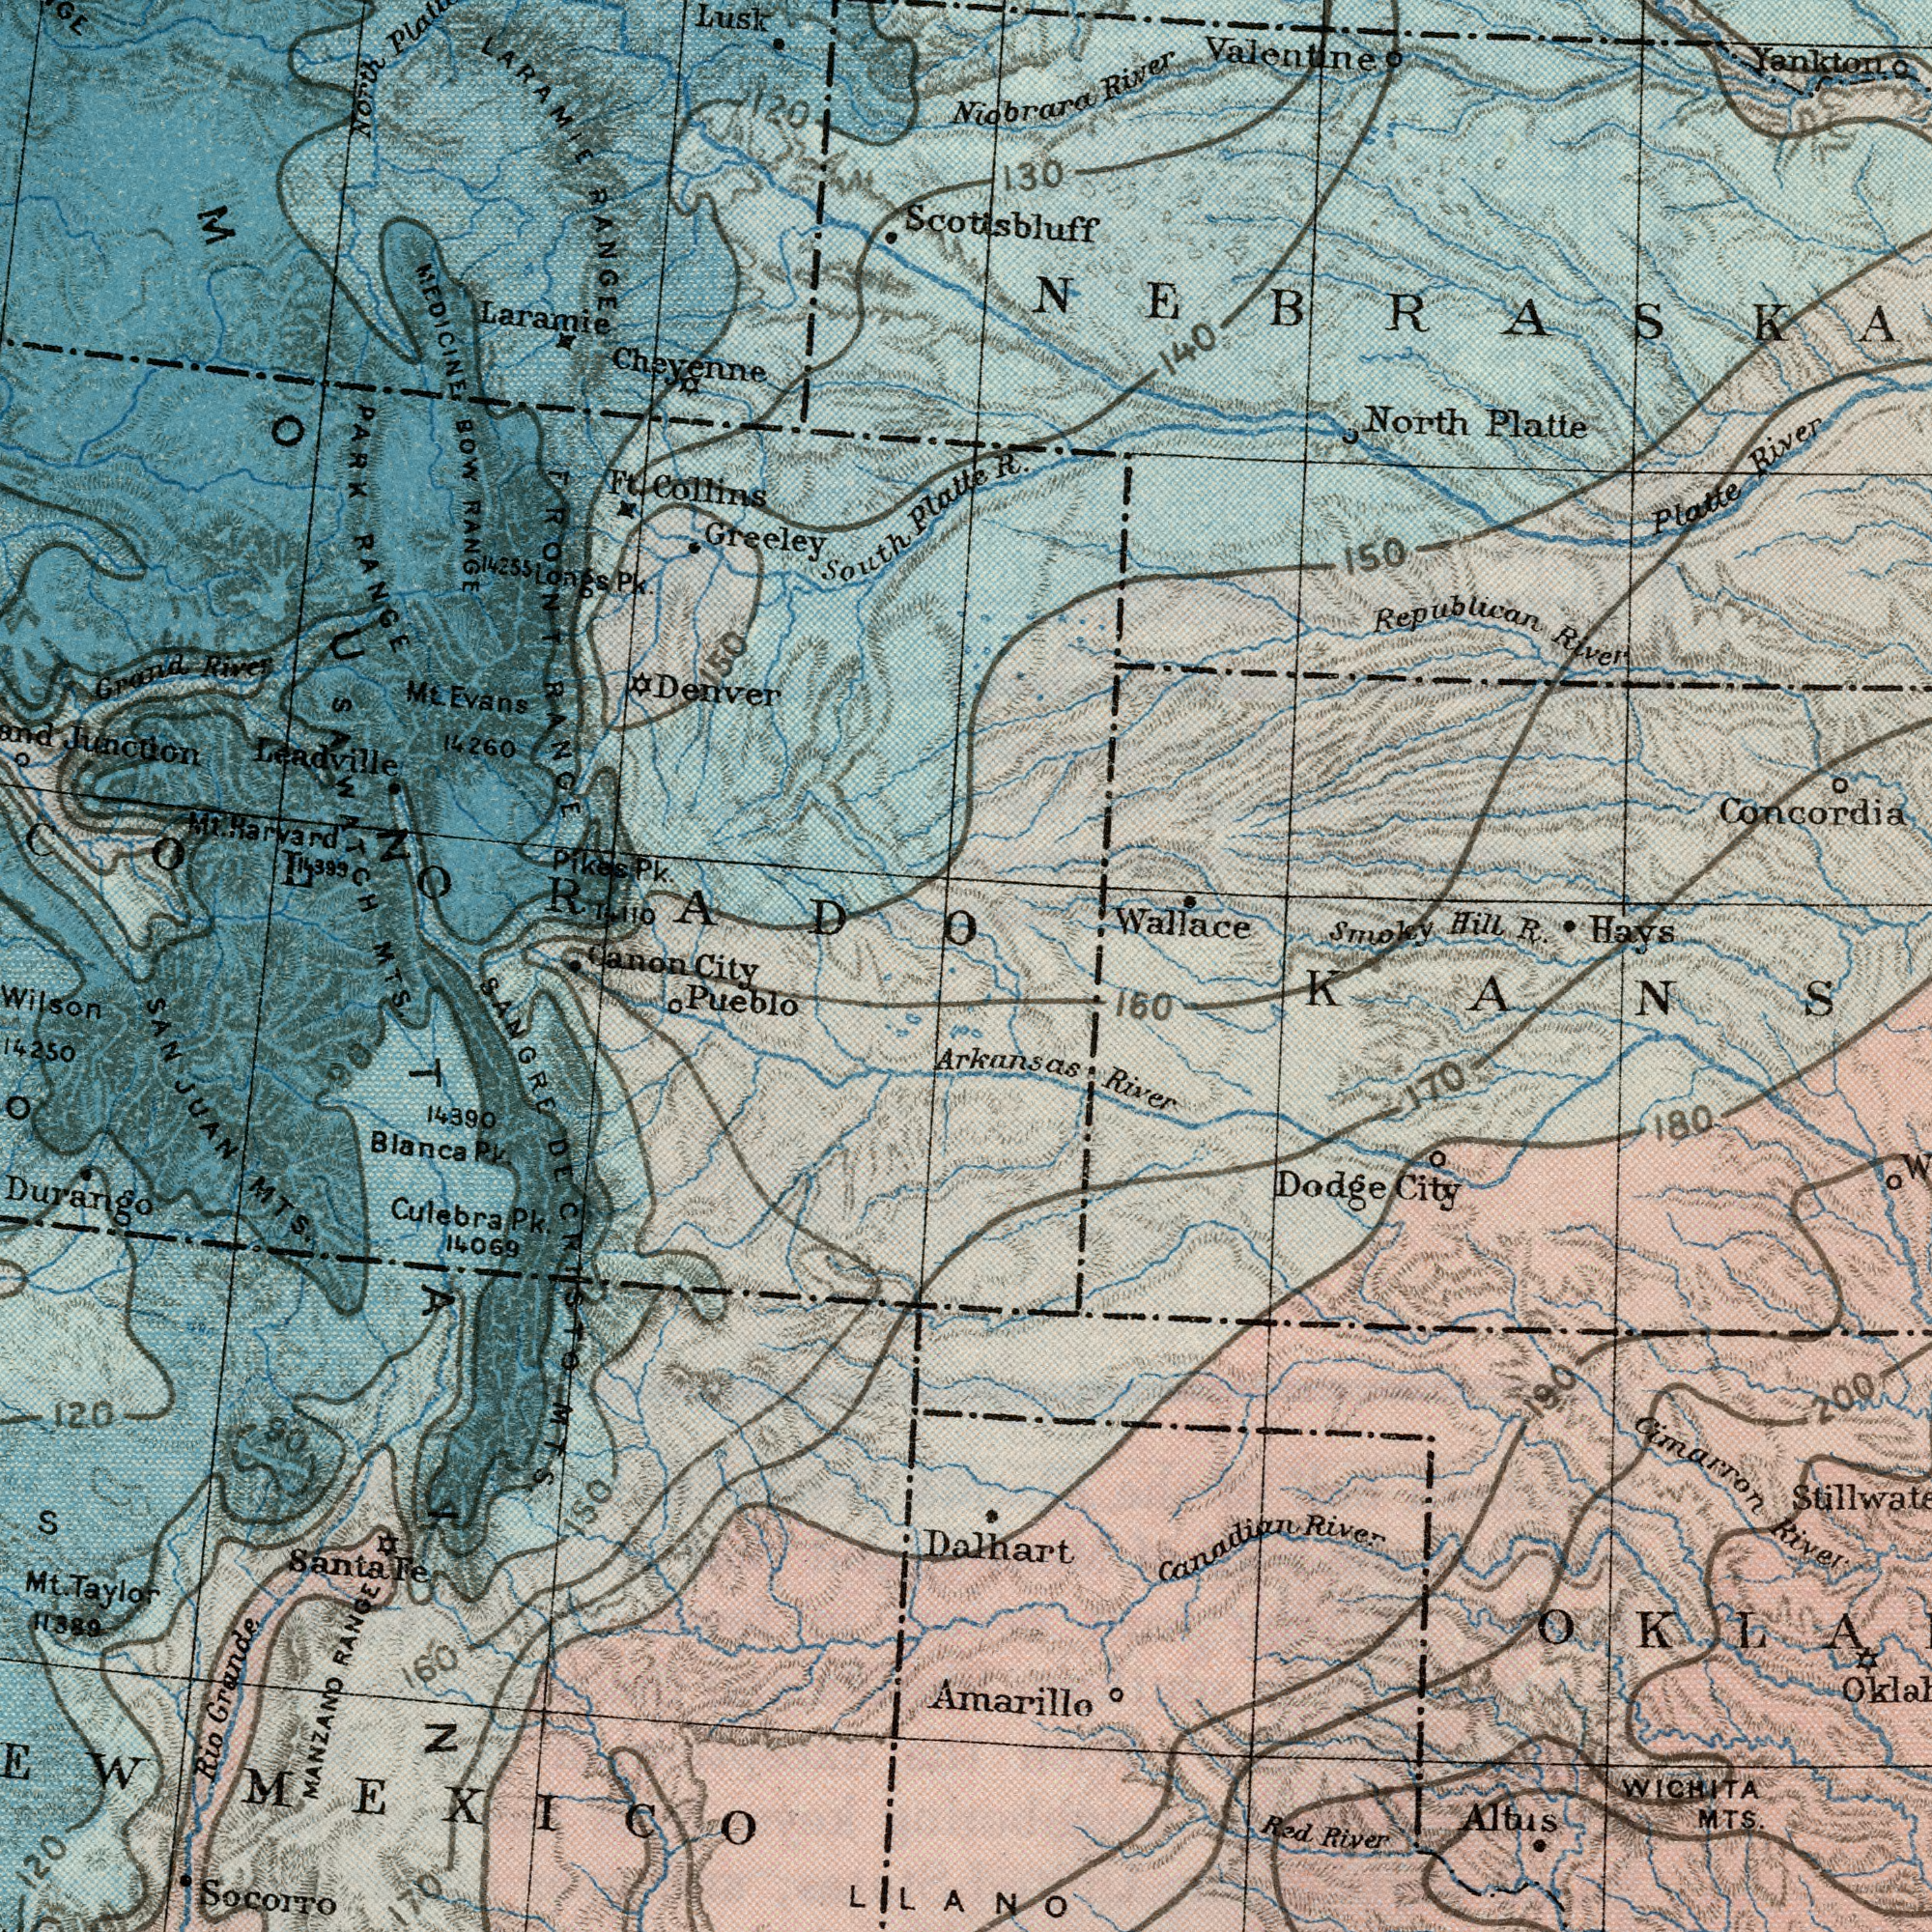What text is shown in the top-left quadrant? PARK RANGE MEDICINE BOW RANGE Leadville LARAMIE RANGE Greeley Denver Lusk North Grand River South Platte Laramie Mt. Evans Langs Pk. Cheyenne Mt. Harvard 14260 Ft. Collins 1.110 Junction 120 150 Pikes Pk. 14255 FRONT RANGE SAWATCH COLORADO Canon What text appears in the top-right area of the image? Concordia Republican River Wallace North Platte Niobrara River Yankton Hays Valentine Smoky Hill R. Platte River R. Scottsbluff 150 140 130 What text can you see in the bottom-right section? LLANO WICHITA MTS. Canadian River Cimarron River Red River Dalhart Arkansas River Dodge City Altus Amarillo 160 170 180 190 200 What text appears in the bottom-left area of the image? Socorro Wilson Rio Grande Pueblo Culebra Pk. Durango SAN JUAN MTS. 11389 MANZAND RANGE 14069 120 SANGRE DE CRISTO MTS. 160 S 120 150 14390 Mt. Taylor MEXICO 170 Blanca Pk. 90 Santa Fe 90 MTS. MOUNTAIN City 